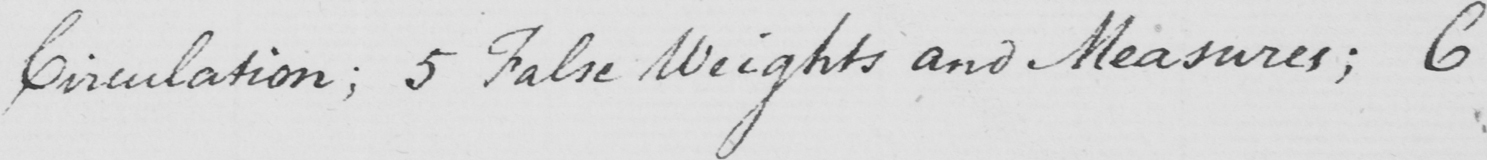Can you read and transcribe this handwriting? Circulation ; 5 False Weights and Measures ; 6 